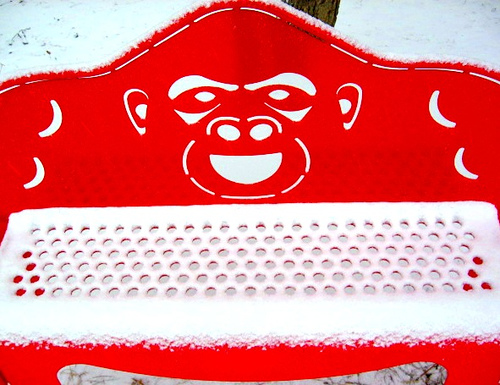<image>
Is there a monkey on the bench? Yes. Looking at the image, I can see the monkey is positioned on top of the bench, with the bench providing support. 